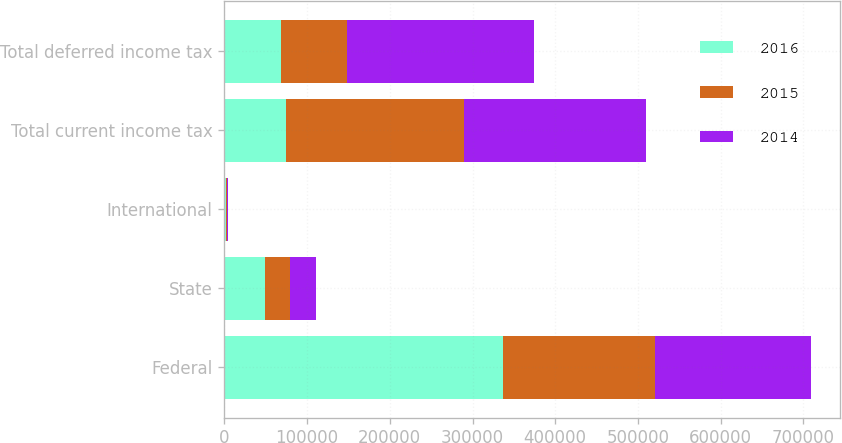<chart> <loc_0><loc_0><loc_500><loc_500><stacked_bar_chart><ecel><fcel>Federal<fcel>State<fcel>International<fcel>Total current income tax<fcel>Total deferred income tax<nl><fcel>2016<fcel>337178<fcel>48771<fcel>1928<fcel>74388.5<fcel>67936<nl><fcel>2015<fcel>183263<fcel>30766<fcel>856<fcel>214885<fcel>80841<nl><fcel>2014<fcel>188302<fcel>30789<fcel>1687<fcel>220778<fcel>225565<nl></chart> 